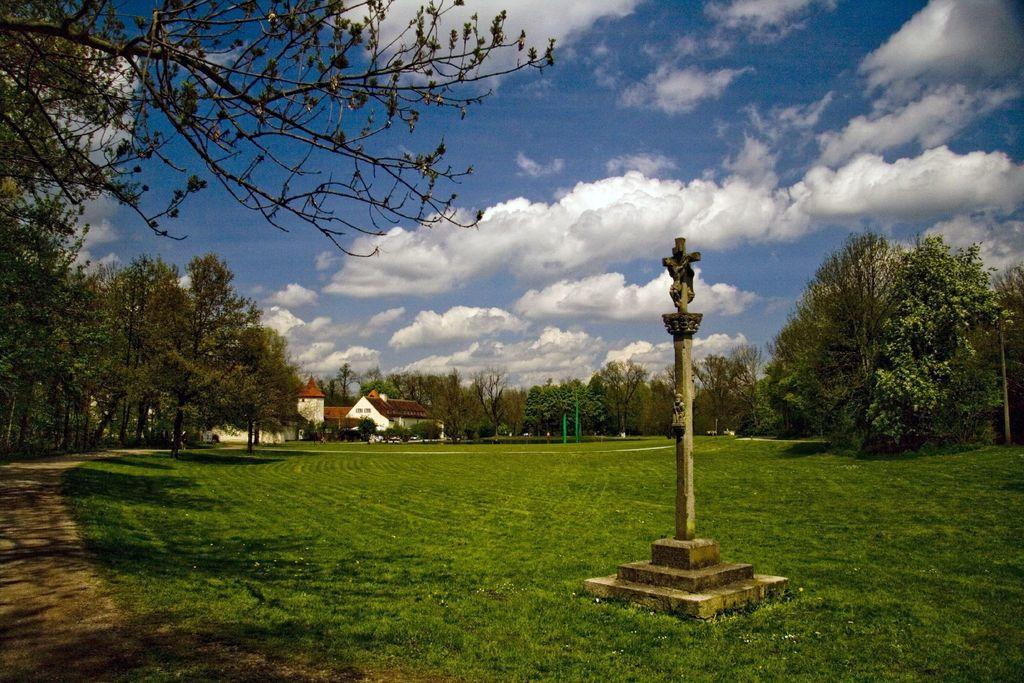What type of vegetation can be seen in the image? There are trees and grass in the image. What structure is present in the image? There is a pole in the image. What can be seen in the background of the image? There are houses and clouds visible in the background of the image. What type of feast is being prepared in the image? There is no indication of a feast or any food preparation in the image. Can you see any teeth in the image? There are no teeth visible in the image, as it features trees, grass, a pole, houses, and clouds. 